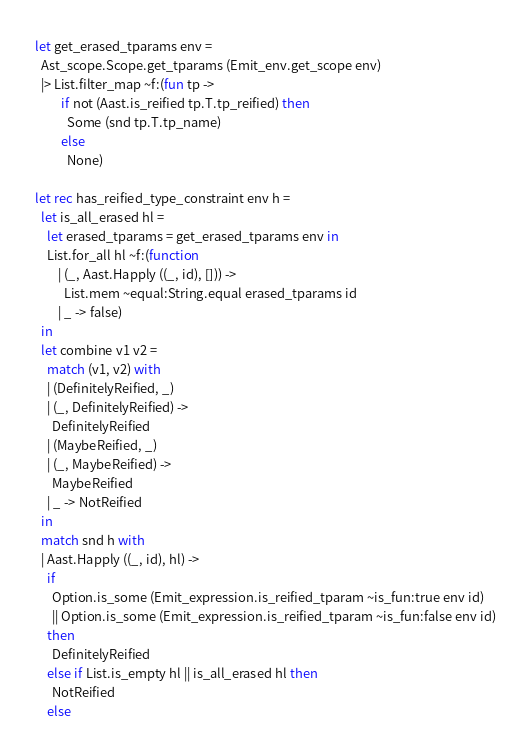Convert code to text. <code><loc_0><loc_0><loc_500><loc_500><_OCaml_>let get_erased_tparams env =
  Ast_scope.Scope.get_tparams (Emit_env.get_scope env)
  |> List.filter_map ~f:(fun tp ->
         if not (Aast.is_reified tp.T.tp_reified) then
           Some (snd tp.T.tp_name)
         else
           None)

let rec has_reified_type_constraint env h =
  let is_all_erased hl =
    let erased_tparams = get_erased_tparams env in
    List.for_all hl ~f:(function
        | (_, Aast.Happly ((_, id), [])) ->
          List.mem ~equal:String.equal erased_tparams id
        | _ -> false)
  in
  let combine v1 v2 =
    match (v1, v2) with
    | (DefinitelyReified, _)
    | (_, DefinitelyReified) ->
      DefinitelyReified
    | (MaybeReified, _)
    | (_, MaybeReified) ->
      MaybeReified
    | _ -> NotReified
  in
  match snd h with
  | Aast.Happly ((_, id), hl) ->
    if
      Option.is_some (Emit_expression.is_reified_tparam ~is_fun:true env id)
      || Option.is_some (Emit_expression.is_reified_tparam ~is_fun:false env id)
    then
      DefinitelyReified
    else if List.is_empty hl || is_all_erased hl then
      NotReified
    else</code> 